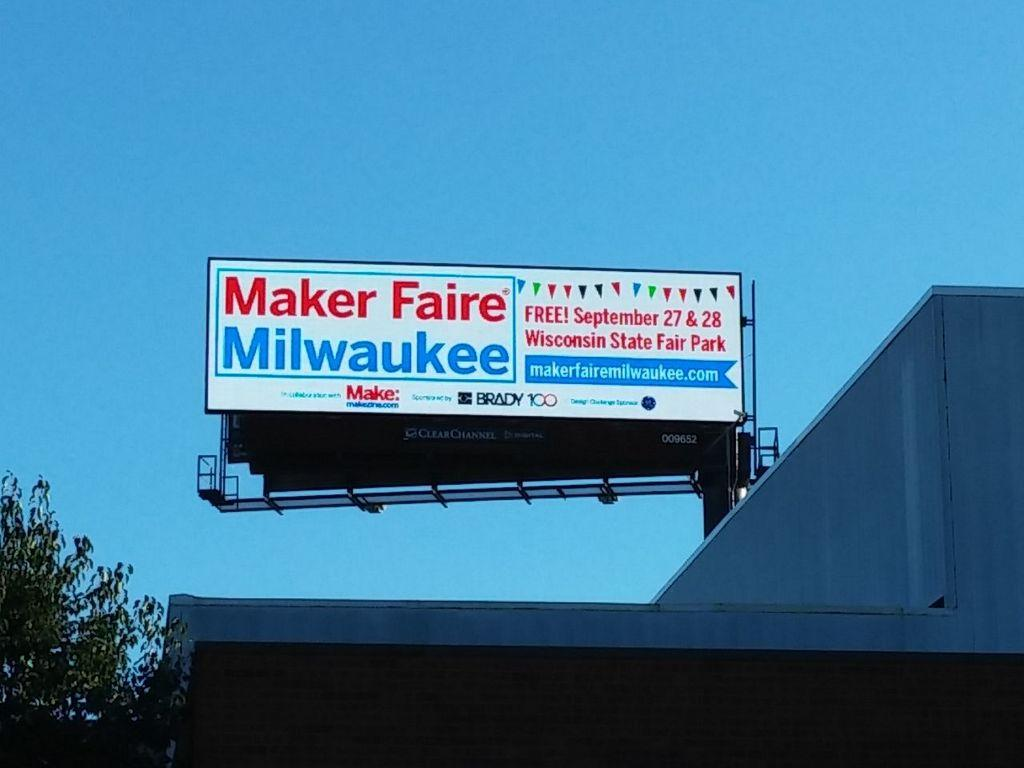<image>
Describe the image concisely. A billboard advertises Maker Faire Milwaukee, September 27 & 28. 